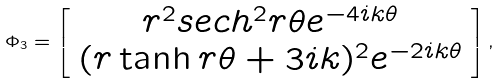Convert formula to latex. <formula><loc_0><loc_0><loc_500><loc_500>\Phi _ { 3 } = \left [ \begin{array} { c } r ^ { 2 } s e c h ^ { 2 } r \theta e ^ { - 4 i k \theta } \\ ( r \tanh r \theta + 3 i k ) ^ { 2 } e ^ { - 2 i k \theta } \end{array} \right ] ,</formula> 